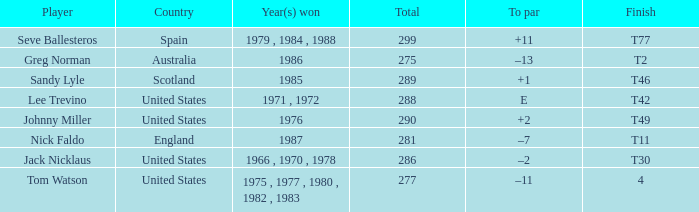What country had a finish of t42? United States. 